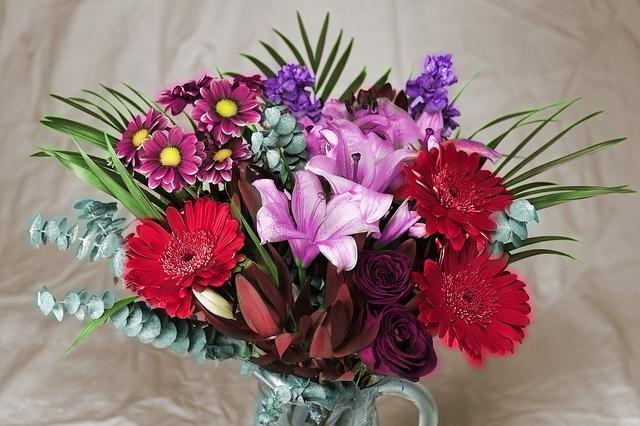How many potted plants can be seen?
Give a very brief answer. 1. 